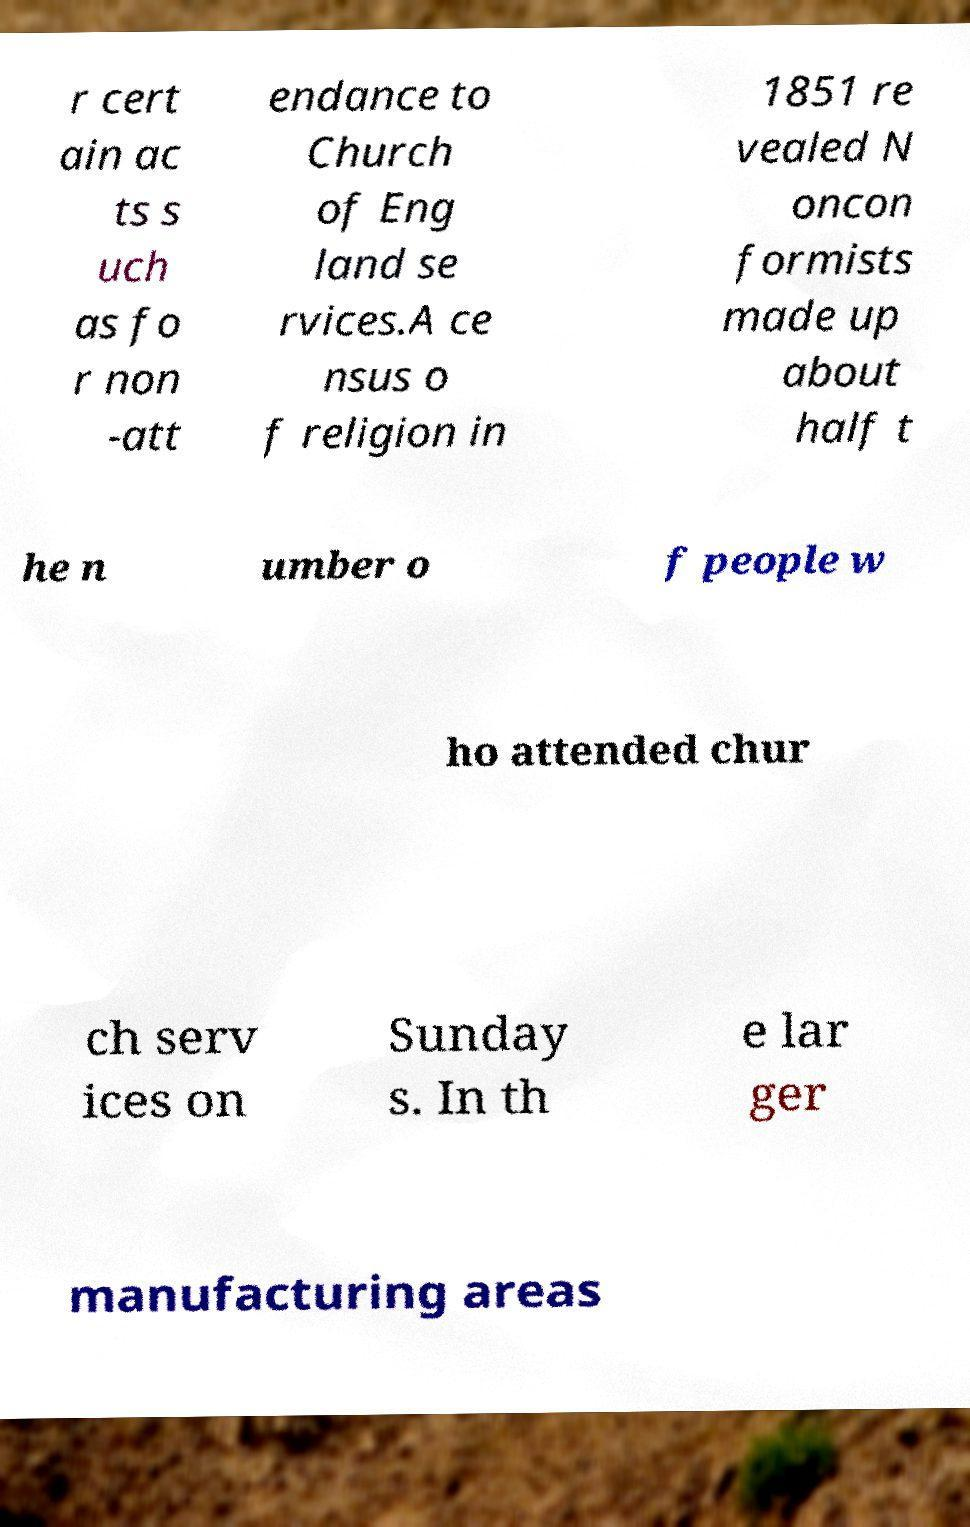There's text embedded in this image that I need extracted. Can you transcribe it verbatim? r cert ain ac ts s uch as fo r non -att endance to Church of Eng land se rvices.A ce nsus o f religion in 1851 re vealed N oncon formists made up about half t he n umber o f people w ho attended chur ch serv ices on Sunday s. In th e lar ger manufacturing areas 